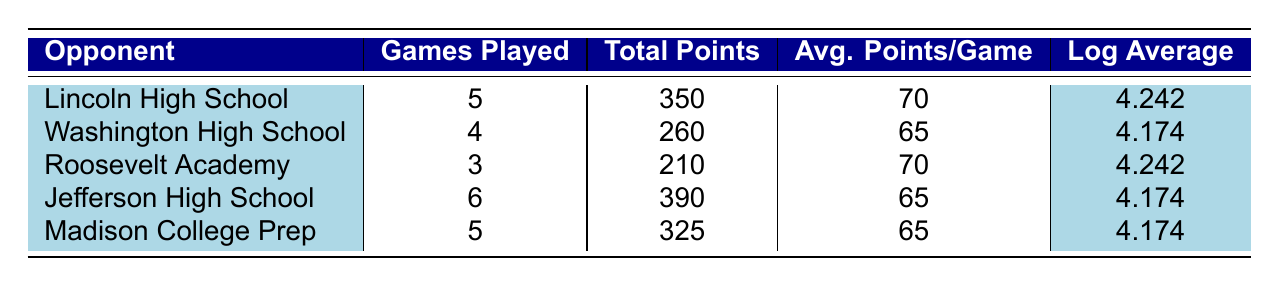What is the average points scored per game against Lincoln High School? The average points scored against Lincoln High School is listed in the table under "Avg. Points/Game", which shows 70.
Answer: 70 How many total points were scored against Washington High School? To find the total points scored against Washington High School, refer to the "Total Points" column, where it indicates 260.
Answer: 260 Which opponent had the highest logarithmic average? The logarithmic averages for Lincoln High School and Roosevelt Academy are both 4.242, which are the highest in the table.
Answer: Lincoln High School and Roosevelt Academy Is the average scoring per game against Madison College Prep greater than the average against Jefferson High School? The average points per game against Madison College Prep is 65, while it is also 65 against Jefferson High School; since both are equal, the answer is no.
Answer: No What is the total number of games played against all opponents? To get the total number of games played, sum the values in the "Games Played" column: 5 (Lincoln) + 4 (Washington) + 3 (Roosevelt) + 6 (Jefferson) + 5 (Madison) = 23 games.
Answer: 23 What is the difference in average points per game between Lincoln High School and Washington High School? Lincoln High School has an average of 70 points per game while Washington High School has 65 points. The difference is 70 - 65 = 5.
Answer: 5 Is it true that all teams except Roosevelt Academy scored less than 70 average points per game? Comparing the average points per game, Lincoln High School and Roosevelt Academy both scored 70, while Washington, Jefferson, and Madison scored 65. Thus, the statement is false as two teams did not score less.
Answer: No How many more total points were scored against Jefferson High School compared to Washington High School? Jefferson High School had 390 total points and Washington High School had 260. The difference is 390 - 260 = 130.
Answer: 130 What is the average logarithmic average across all opponents? To find the average of the logarithmic averages, sum them: 4.242 (Lincoln) + 4.174 (Washington) + 4.242 (Roosevelt) + 4.174 (Jefferson) + 4.174 (Madison) = 20.056, and then divide by 5 (the number of opponents), which equals 4.0112.
Answer: 4.0112 